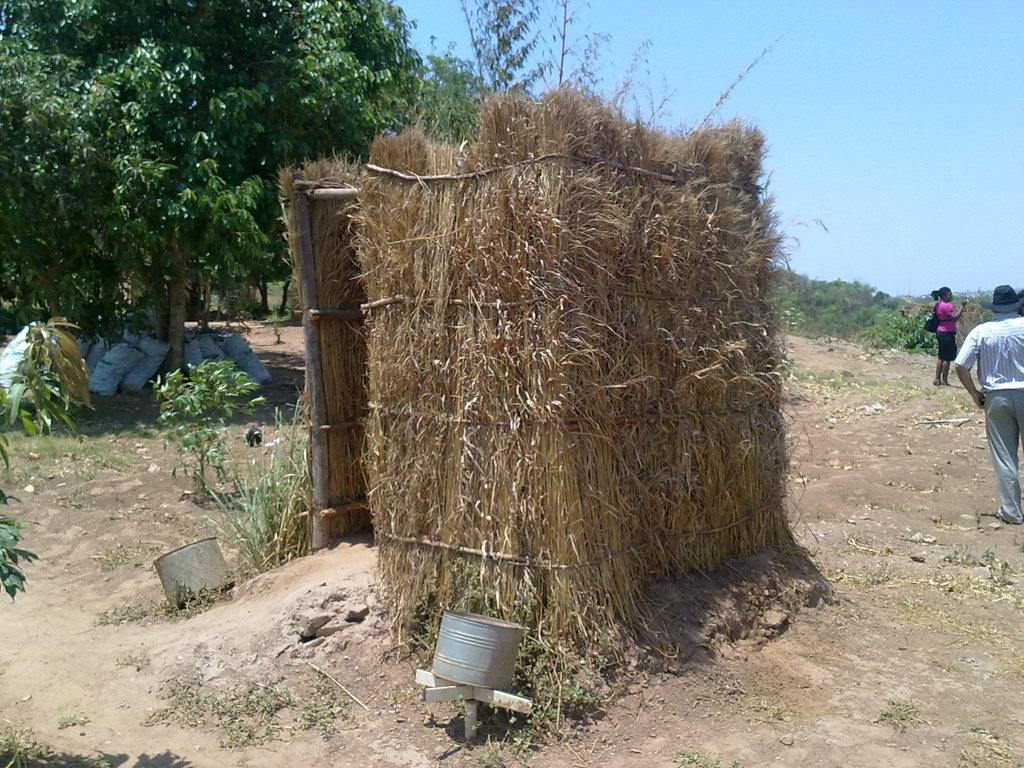How many people are in the image? There are people in the image, but the exact number is not specified. What is visible beneath the people's feet in the image? The ground is visible in the image. What type of vegetation can be seen in the image? There is grass and plants in the image. What objects are being carried by the people in the image? There are bags in the image. What type of trees are present in the image? There are trees in the image, but the specific type is not mentioned. What is visible in the background of the image? There is sky visible in the background of the image. What type of toothpaste is being used by the people in the image? There is no toothpaste present in the image. How much credit is being discussed by the people in the image? There is no mention of credit or any financial transactions in the image. 